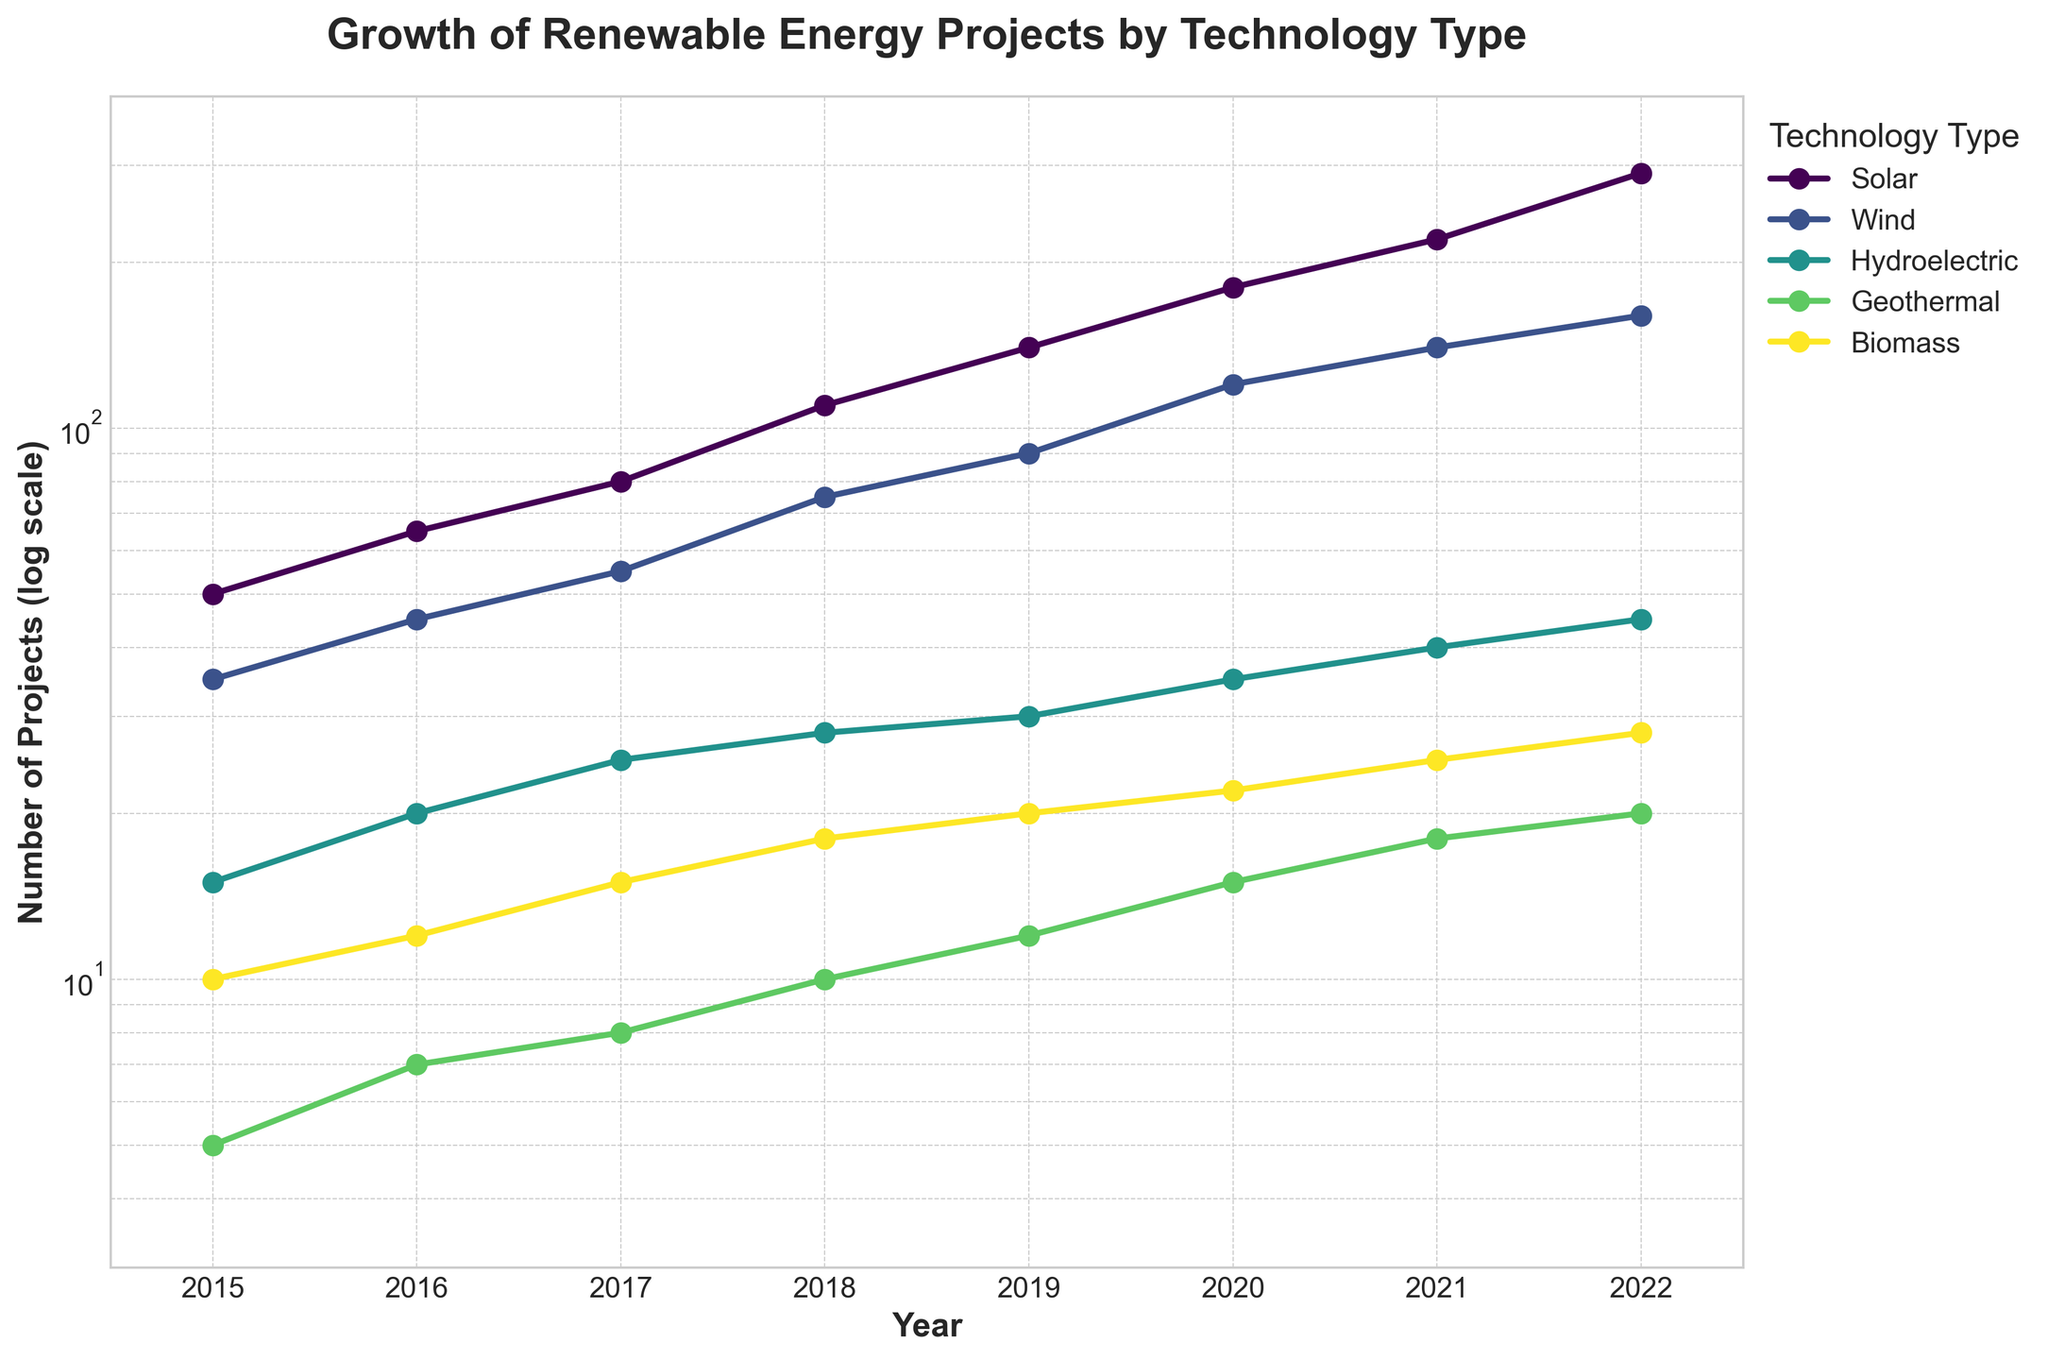How many new solar projects were started in 2020? According to the figure, look at the point corresponding to the year 2020 for Solar.
Answer: 180 What is the title of the figure? Refer to the text at the top center of the plot.
Answer: Growth of Renewable Energy Projects by Technology Type Which technology type had the fewest projects started in 2015? Compare the data points for each technology type in the year 2015 and identify the smallest number.
Answer: Geothermal How did the number of wind projects change from 2017 to 2020? Find the data points for Wind projects in 2017 and 2020, then calculate the difference.
Answer: Increased by 65 Which technology type showed the fastest growth rate from 2015 to 2022? Compare the slope of the lines for each technology type between 2015 and 2022 to determine the steepest one.
Answer: Solar What is the range of the y-axis in the figure? Identify the minimum and maximum values indicated on the y-axis.
Answer: 3 to 400 How many total renewable energy projects were started in 2021? Sum up the data points for each technology type in the year 2021.
Answer: 443 Which technology had the greatest number of projects in both 2018 and 2022? Compare the data points for each technology in 2018 and 2022.
Answer: Solar What is the main trend for biomass projects from 2015 to 2022? Observe the line representing biomass from 2015 to 2022 and describe its pattern.
Answer: Increasing Between 2019 and 2022, which technology type had the smallest increase in projects? Calculate the difference in the number of projects for each technology type between 2019 and 2022 and identify the smallest.
Answer: Geothermal 